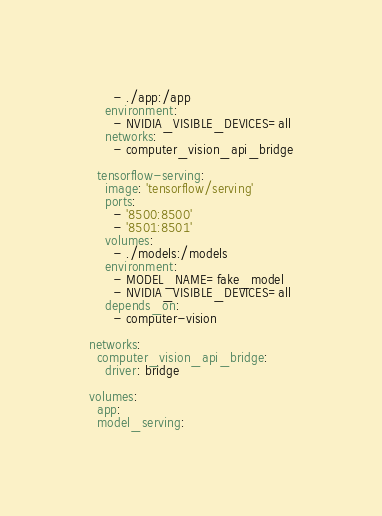Convert code to text. <code><loc_0><loc_0><loc_500><loc_500><_YAML_>      - ./app:/app
    environment:
      - NVIDIA_VISIBLE_DEVICES=all
    networks:
      - computer_vision_api_bridge
    
  tensorflow-serving:
    image: 'tensorflow/serving'
    ports:
      - '8500:8500'
      - '8501:8501'
    volumes:
      - ./models:/models
    environment:
      - MODEL_NAME=fake_model
      - NVIDIA_VISIBLE_DEVICES=all
    depends_on:
      - computer-vision

networks:
  computer_vision_api_bridge:
    driver: bridge

volumes:
  app:
  model_serving:
</code> 